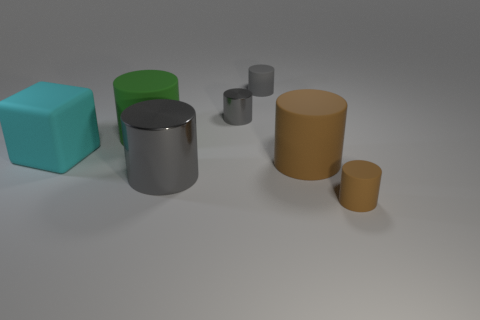How many gray cylinders must be subtracted to get 1 gray cylinders? 2 Add 1 small metallic objects. How many objects exist? 8 Subtract all big gray shiny cylinders. How many cylinders are left? 5 Subtract 1 cylinders. How many cylinders are left? 5 Subtract all gray cylinders. How many cylinders are left? 3 Subtract all blocks. How many objects are left? 6 Subtract all red cylinders. Subtract all yellow balls. How many cylinders are left? 6 Subtract all gray cylinders. How many gray blocks are left? 0 Subtract all brown matte things. Subtract all large cyan cubes. How many objects are left? 4 Add 4 tiny gray metallic things. How many tiny gray metallic things are left? 5 